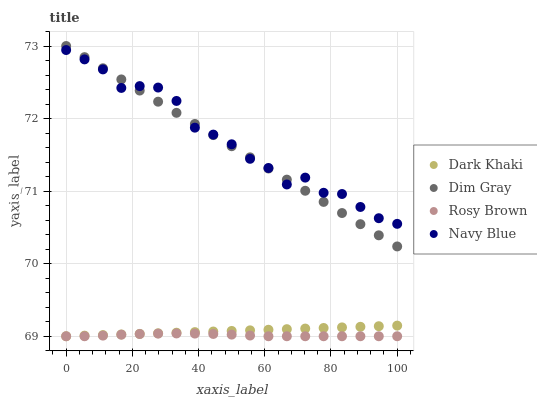Does Rosy Brown have the minimum area under the curve?
Answer yes or no. Yes. Does Navy Blue have the maximum area under the curve?
Answer yes or no. Yes. Does Navy Blue have the minimum area under the curve?
Answer yes or no. No. Does Rosy Brown have the maximum area under the curve?
Answer yes or no. No. Is Dark Khaki the smoothest?
Answer yes or no. Yes. Is Navy Blue the roughest?
Answer yes or no. Yes. Is Rosy Brown the smoothest?
Answer yes or no. No. Is Rosy Brown the roughest?
Answer yes or no. No. Does Dark Khaki have the lowest value?
Answer yes or no. Yes. Does Navy Blue have the lowest value?
Answer yes or no. No. Does Dim Gray have the highest value?
Answer yes or no. Yes. Does Navy Blue have the highest value?
Answer yes or no. No. Is Rosy Brown less than Navy Blue?
Answer yes or no. Yes. Is Navy Blue greater than Rosy Brown?
Answer yes or no. Yes. Does Dark Khaki intersect Rosy Brown?
Answer yes or no. Yes. Is Dark Khaki less than Rosy Brown?
Answer yes or no. No. Is Dark Khaki greater than Rosy Brown?
Answer yes or no. No. Does Rosy Brown intersect Navy Blue?
Answer yes or no. No. 